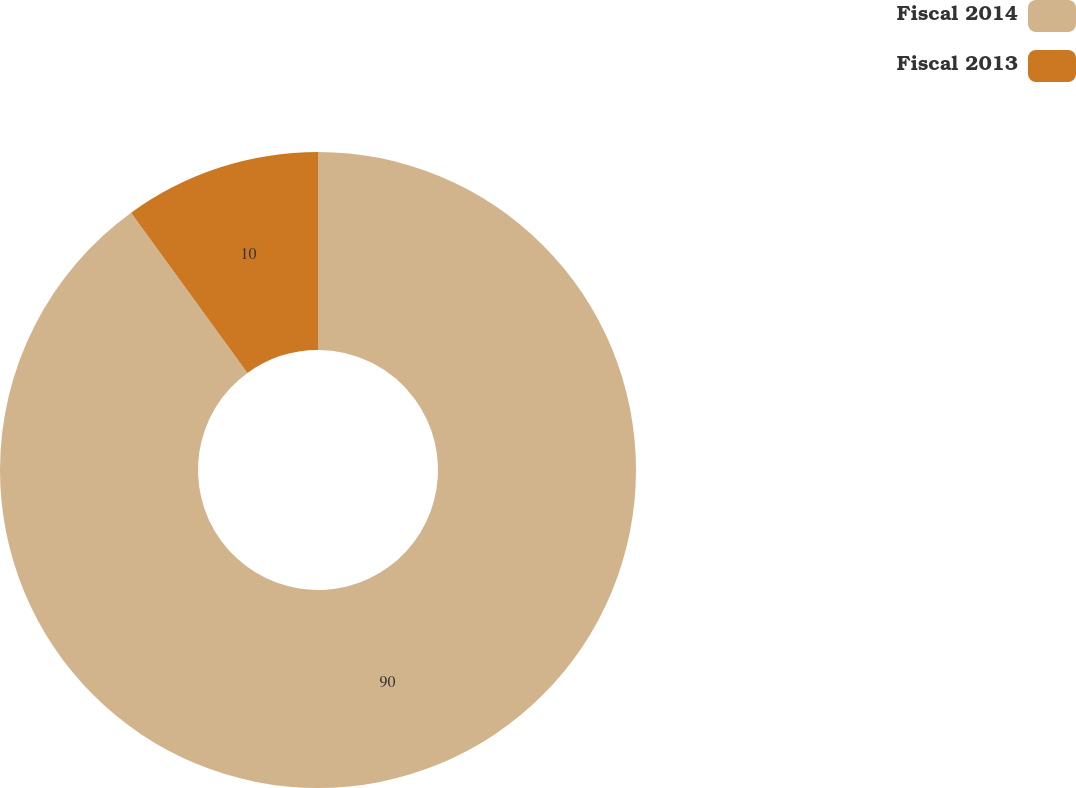<chart> <loc_0><loc_0><loc_500><loc_500><pie_chart><fcel>Fiscal 2014<fcel>Fiscal 2013<nl><fcel>90.0%<fcel>10.0%<nl></chart> 